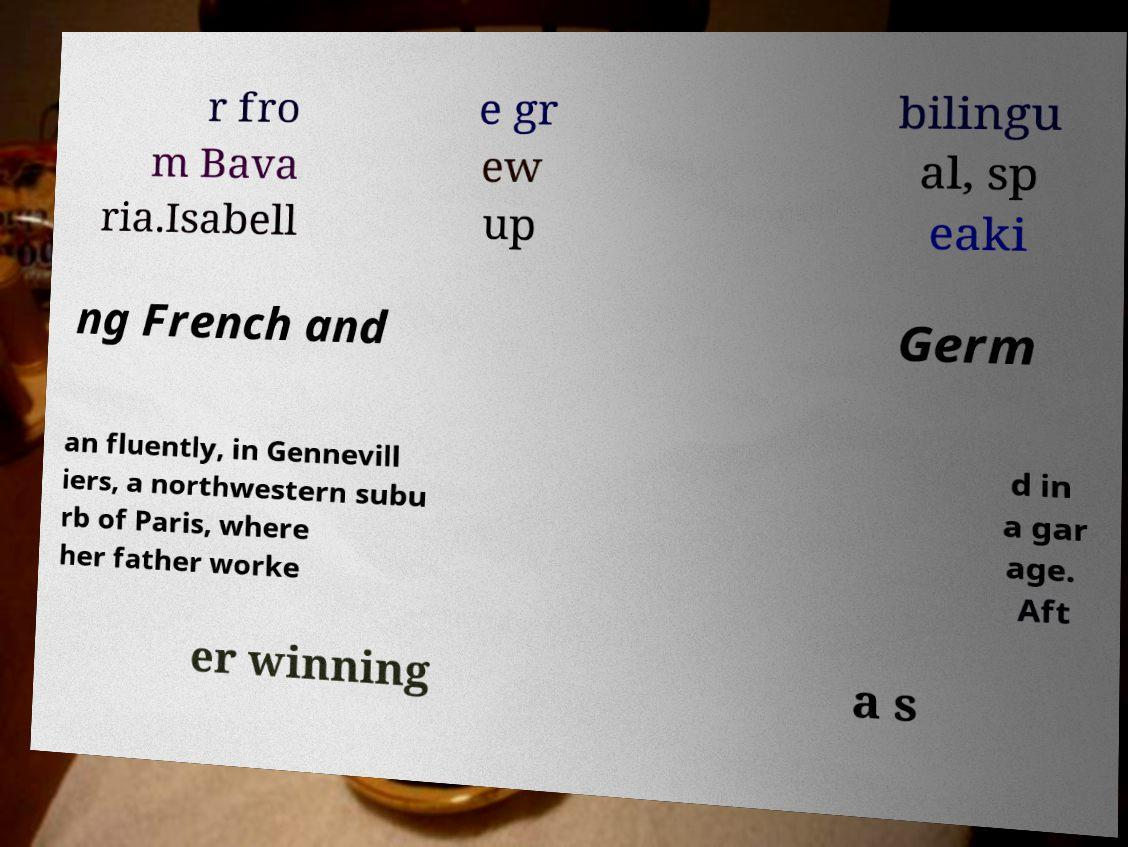Please read and relay the text visible in this image. What does it say? r fro m Bava ria.Isabell e gr ew up bilingu al, sp eaki ng French and Germ an fluently, in Gennevill iers, a northwestern subu rb of Paris, where her father worke d in a gar age. Aft er winning a s 